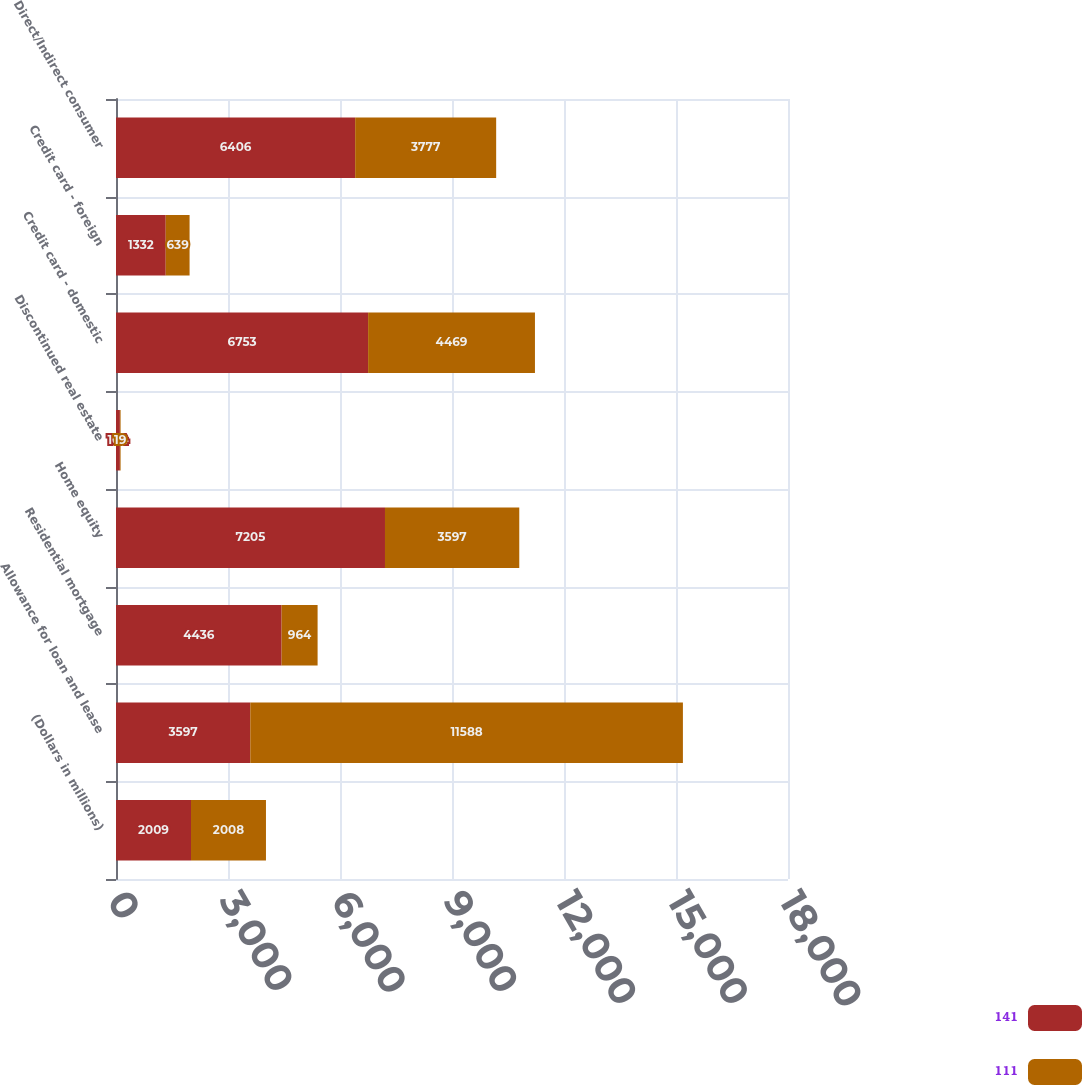<chart> <loc_0><loc_0><loc_500><loc_500><stacked_bar_chart><ecel><fcel>(Dollars in millions)<fcel>Allowance for loan and lease<fcel>Residential mortgage<fcel>Home equity<fcel>Discontinued real estate<fcel>Credit card - domestic<fcel>Credit card - foreign<fcel>Direct/Indirect consumer<nl><fcel>141<fcel>2009<fcel>3597<fcel>4436<fcel>7205<fcel>104<fcel>6753<fcel>1332<fcel>6406<nl><fcel>111<fcel>2008<fcel>11588<fcel>964<fcel>3597<fcel>19<fcel>4469<fcel>639<fcel>3777<nl></chart> 